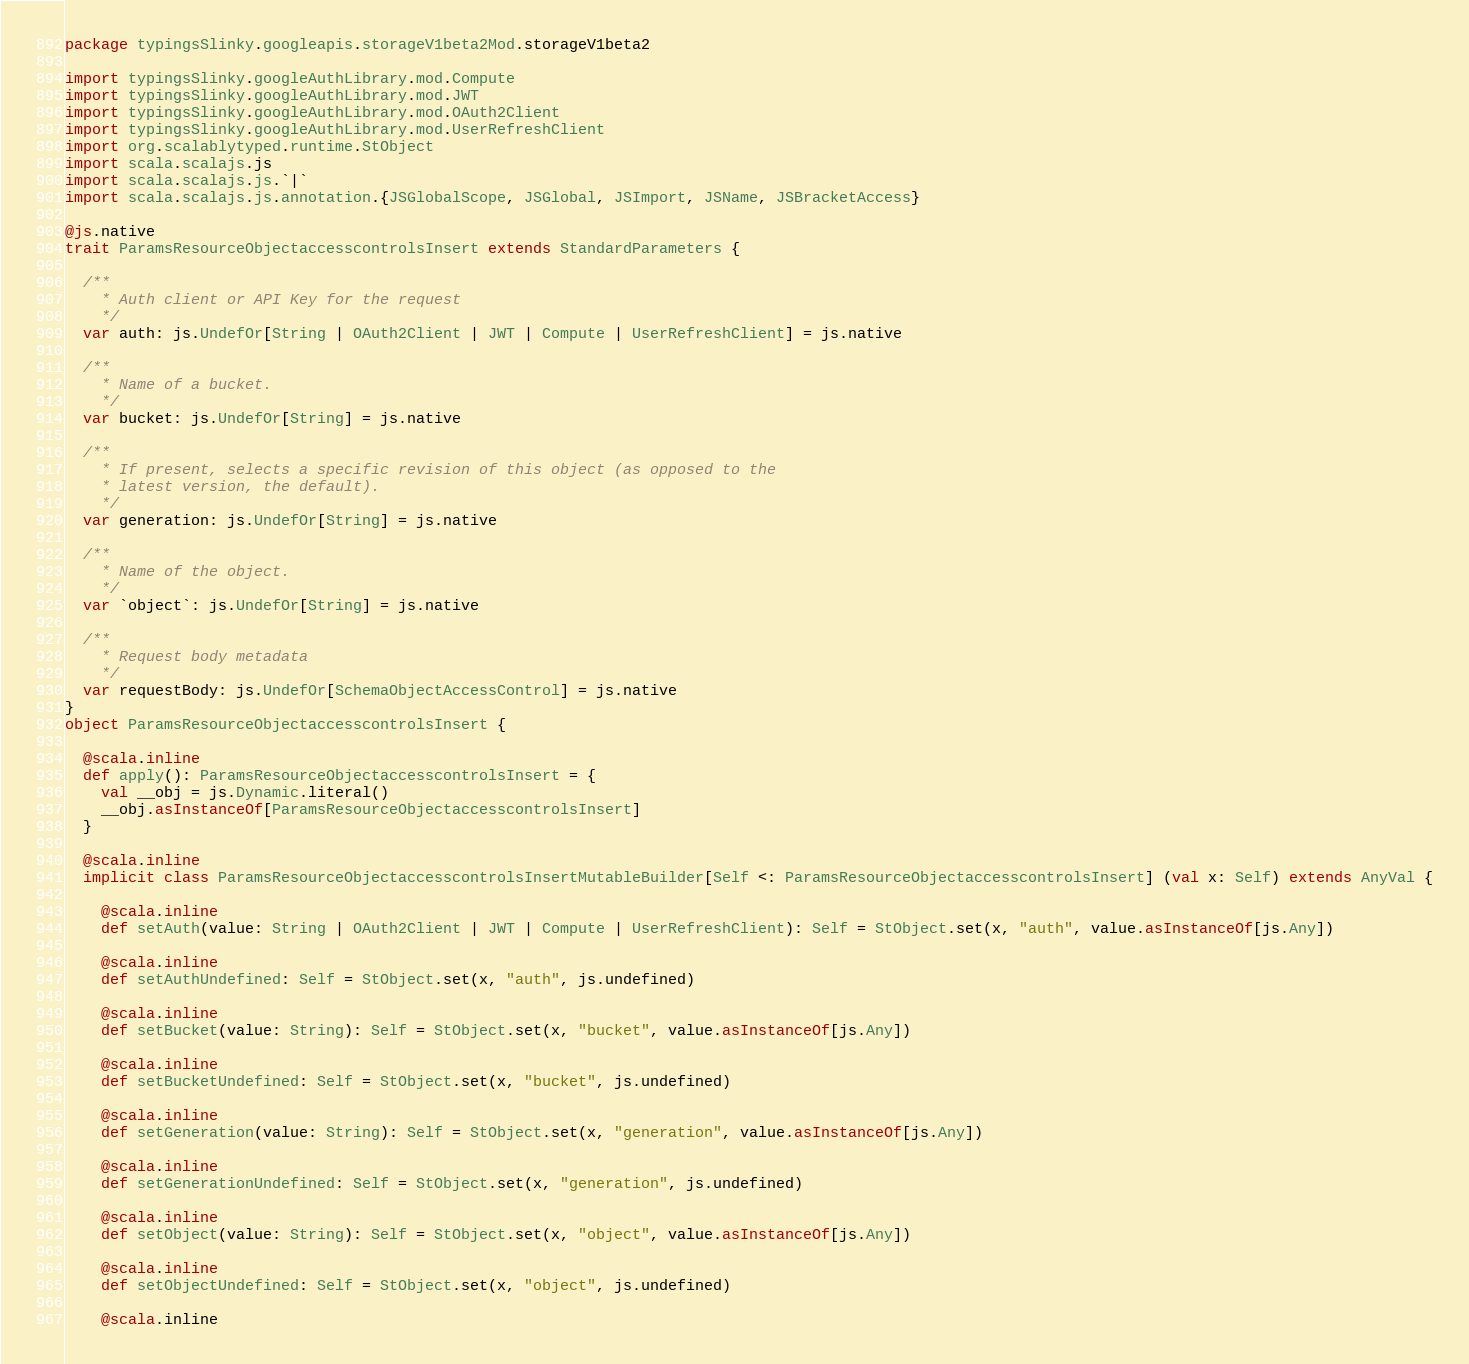<code> <loc_0><loc_0><loc_500><loc_500><_Scala_>package typingsSlinky.googleapis.storageV1beta2Mod.storageV1beta2

import typingsSlinky.googleAuthLibrary.mod.Compute
import typingsSlinky.googleAuthLibrary.mod.JWT
import typingsSlinky.googleAuthLibrary.mod.OAuth2Client
import typingsSlinky.googleAuthLibrary.mod.UserRefreshClient
import org.scalablytyped.runtime.StObject
import scala.scalajs.js
import scala.scalajs.js.`|`
import scala.scalajs.js.annotation.{JSGlobalScope, JSGlobal, JSImport, JSName, JSBracketAccess}

@js.native
trait ParamsResourceObjectaccesscontrolsInsert extends StandardParameters {
  
  /**
    * Auth client or API Key for the request
    */
  var auth: js.UndefOr[String | OAuth2Client | JWT | Compute | UserRefreshClient] = js.native
  
  /**
    * Name of a bucket.
    */
  var bucket: js.UndefOr[String] = js.native
  
  /**
    * If present, selects a specific revision of this object (as opposed to the
    * latest version, the default).
    */
  var generation: js.UndefOr[String] = js.native
  
  /**
    * Name of the object.
    */
  var `object`: js.UndefOr[String] = js.native
  
  /**
    * Request body metadata
    */
  var requestBody: js.UndefOr[SchemaObjectAccessControl] = js.native
}
object ParamsResourceObjectaccesscontrolsInsert {
  
  @scala.inline
  def apply(): ParamsResourceObjectaccesscontrolsInsert = {
    val __obj = js.Dynamic.literal()
    __obj.asInstanceOf[ParamsResourceObjectaccesscontrolsInsert]
  }
  
  @scala.inline
  implicit class ParamsResourceObjectaccesscontrolsInsertMutableBuilder[Self <: ParamsResourceObjectaccesscontrolsInsert] (val x: Self) extends AnyVal {
    
    @scala.inline
    def setAuth(value: String | OAuth2Client | JWT | Compute | UserRefreshClient): Self = StObject.set(x, "auth", value.asInstanceOf[js.Any])
    
    @scala.inline
    def setAuthUndefined: Self = StObject.set(x, "auth", js.undefined)
    
    @scala.inline
    def setBucket(value: String): Self = StObject.set(x, "bucket", value.asInstanceOf[js.Any])
    
    @scala.inline
    def setBucketUndefined: Self = StObject.set(x, "bucket", js.undefined)
    
    @scala.inline
    def setGeneration(value: String): Self = StObject.set(x, "generation", value.asInstanceOf[js.Any])
    
    @scala.inline
    def setGenerationUndefined: Self = StObject.set(x, "generation", js.undefined)
    
    @scala.inline
    def setObject(value: String): Self = StObject.set(x, "object", value.asInstanceOf[js.Any])
    
    @scala.inline
    def setObjectUndefined: Self = StObject.set(x, "object", js.undefined)
    
    @scala.inline</code> 